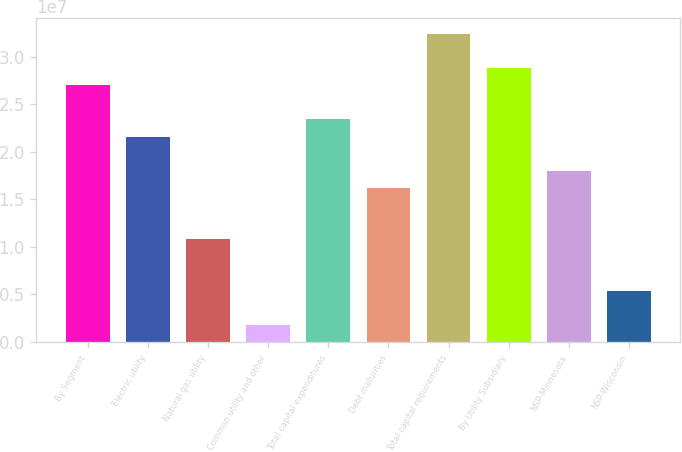<chart> <loc_0><loc_0><loc_500><loc_500><bar_chart><fcel>By Segment<fcel>Electric utility<fcel>Natural gas utility<fcel>Common utility and other<fcel>Total capital expenditures<fcel>Debt maturities<fcel>Total capital requirements<fcel>By Utility Subsidiary<fcel>NSP-Minnesota<fcel>NSP-Wisconsin<nl><fcel>2.7003e+07<fcel>2.16024e+07<fcel>1.08012e+07<fcel>1.80022e+06<fcel>2.34026e+07<fcel>1.62018e+07<fcel>3.24036e+07<fcel>2.88032e+07<fcel>1.8002e+07<fcel>5.40061e+06<nl></chart> 